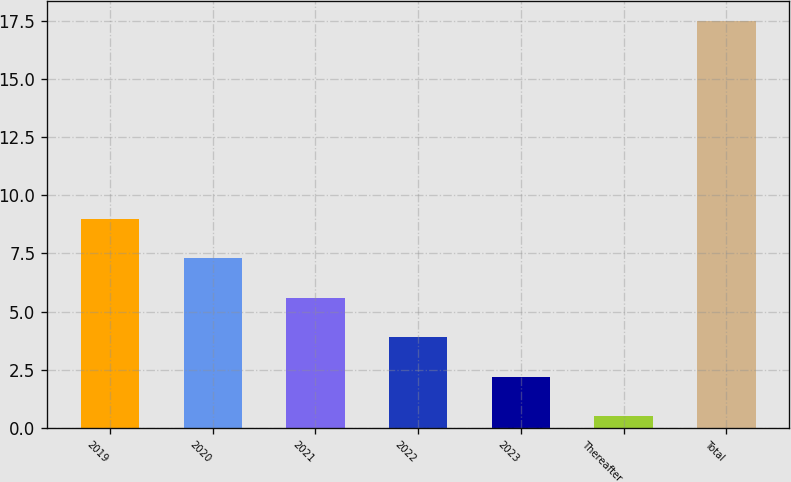Convert chart. <chart><loc_0><loc_0><loc_500><loc_500><bar_chart><fcel>2019<fcel>2020<fcel>2021<fcel>2022<fcel>2023<fcel>Thereafter<fcel>Total<nl><fcel>9<fcel>7.3<fcel>5.6<fcel>3.9<fcel>2.2<fcel>0.5<fcel>17.5<nl></chart> 